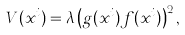Convert formula to latex. <formula><loc_0><loc_0><loc_500><loc_500>V ( x ^ { i } ) = \lambda \left ( g ( x ^ { i } ) f ( x ^ { i } ) \right ) ^ { 2 } ,</formula> 